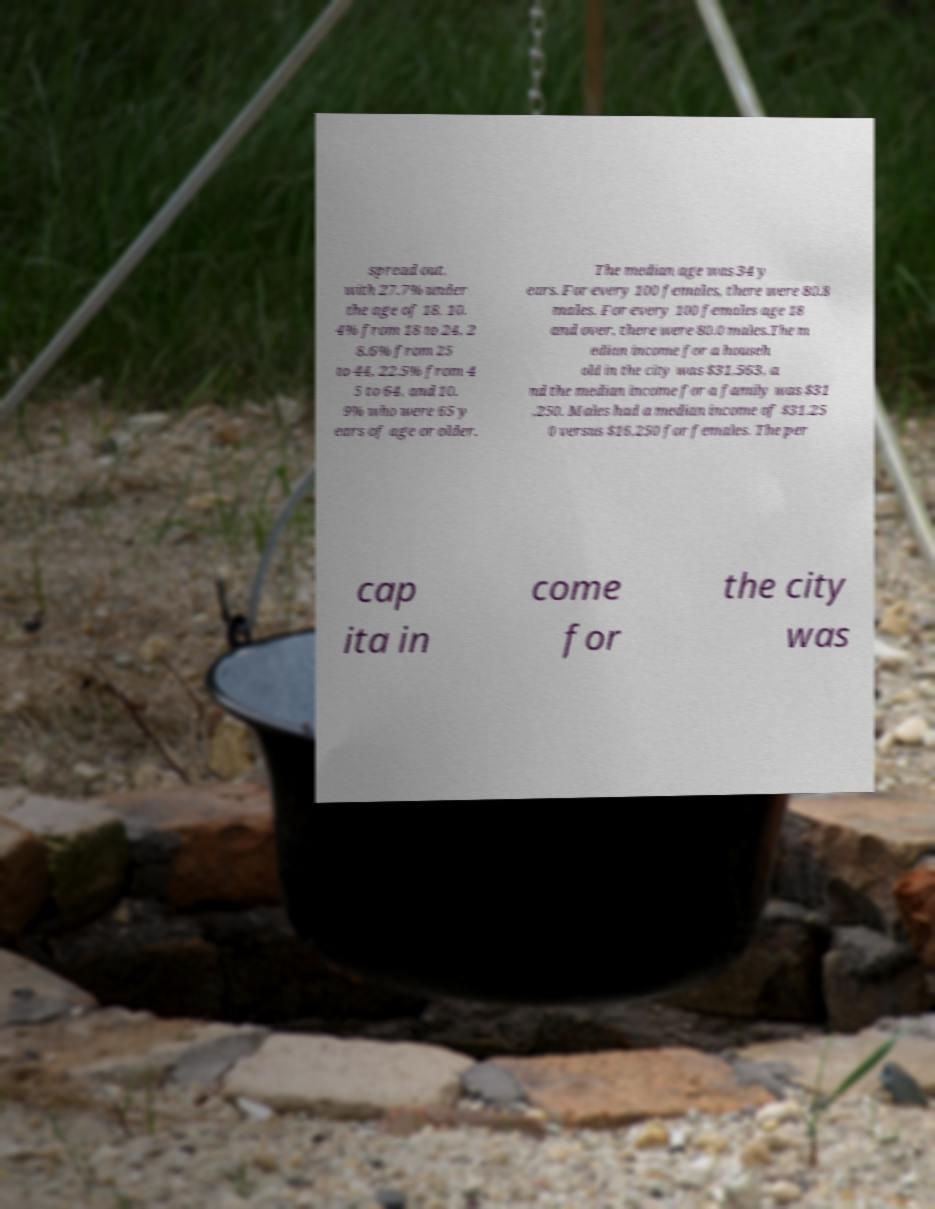Could you extract and type out the text from this image? spread out, with 27.7% under the age of 18, 10. 4% from 18 to 24, 2 8.6% from 25 to 44, 22.5% from 4 5 to 64, and 10. 9% who were 65 y ears of age or older. The median age was 34 y ears. For every 100 females, there were 80.8 males. For every 100 females age 18 and over, there were 80.0 males.The m edian income for a househ old in the city was $31,563, a nd the median income for a family was $31 ,250. Males had a median income of $31,25 0 versus $16,250 for females. The per cap ita in come for the city was 